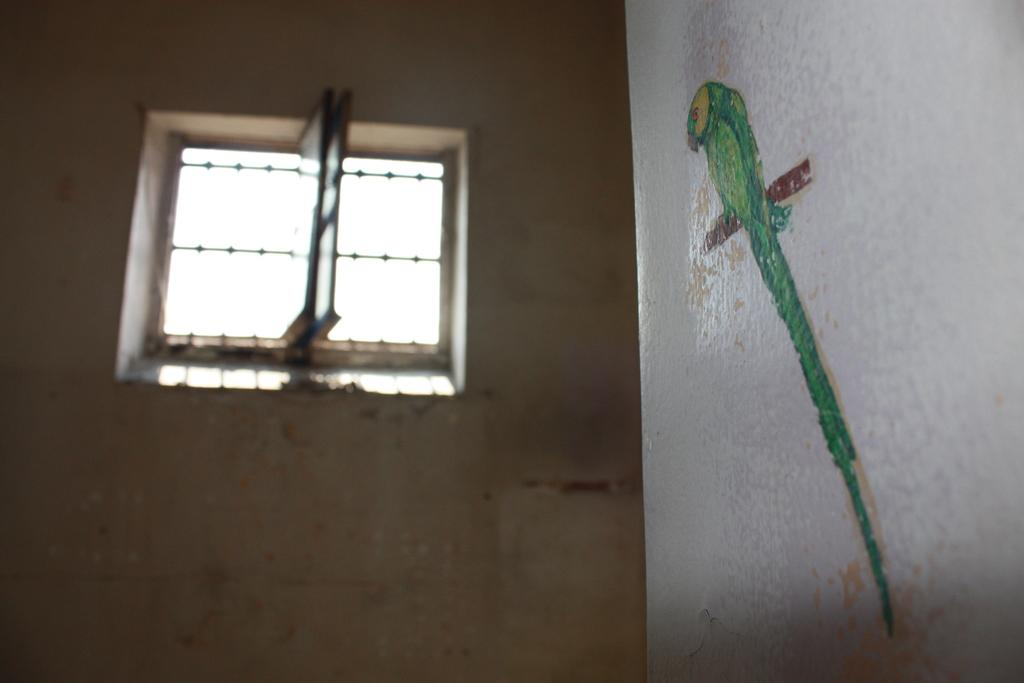What is depicted on the painting that is visible on the wall in the image? There is a painting of a parrot on the wall in the image. Can you describe the architectural features in the image? The image appears to have a window with doors. What type of error can be seen in the painting of the parrot? There is no error present in the painting of the parrot; it is a depiction of a parrot. What type of farm animals can be seen in the image? There are no farm animals present in the image. 